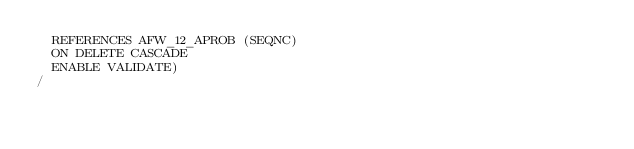Convert code to text. <code><loc_0><loc_0><loc_500><loc_500><_SQL_>  REFERENCES AFW_12_APROB (SEQNC)
  ON DELETE CASCADE
  ENABLE VALIDATE)
/
</code> 